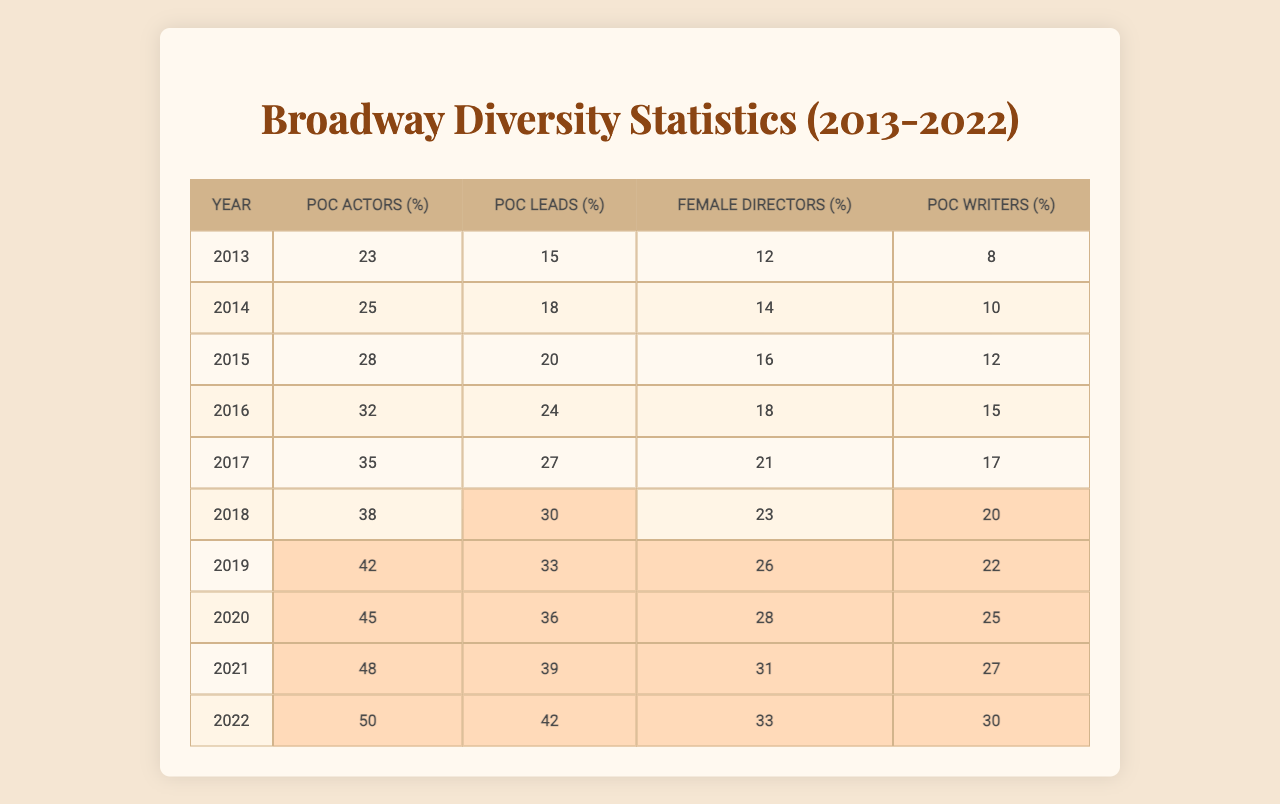What was the percentage of POC actors in 2015? From the table, the row for the year 2015 shows that the percentage of POC actors is 28%.
Answer: 28% In which year did the percentage of female directors first reach 20%? Looking at the data, the percentage of female directors first reaches 21% in 2017, as this is the first year where it is equal to or greater than 20%.
Answer: 2017 What is the average percentage of POC leads from 2019 to 2022? The percentages for POC leads from 2019 to 2022 are 33%, 36%, 39%, and 42%. Adding these together gives us 33 + 36 + 39 + 42 = 150. Dividing by 4 yields an average of 150/4 = 37.5%.
Answer: 37.5% Did the percentage of POC writers ever exceed 25% in the given years? By examining the table, the percentage of POC writers does exceed 25% in the years 2020 (25%), 2021 (27%), and 2022 (30%). Thus, the statement is true.
Answer: Yes What was the increase in the percentage of POC actors from 2013 to 2022? The percentage of POC actors in 2013 was 23% and in 2022 was 50%. The difference is calculated as 50 - 23 = 27%.
Answer: 27% In which year did the percentage of POC writers experience its highest growth compared to the previous year? Evaluating the percentages for POC writers: 8% in 2013, 10% in 2014 (2% growth), 12% in 2015 (2% growth), 15% in 2016 (3% growth), 17% in 2017 (2% growth), 20% in 2018 (3% growth), 22% in 2019 (2% growth), 25% in 2020 (3% growth), 27% in 2021 (2% growth), and 30% in 2022 (3% growth). The highest growth of 3% is observed in 2016, 2018, 2020, and 2022.
Answer: 2016, 2018, 2020, and 2022 What trend can be observed in the percentage of female directors from 2013 to 2022? Analyzing the data shows a consistent upward trend in the percentage of female directors over the years: it starts at 12% in 2013 and rises to 33% in 2022. This indicates ongoing improvement in gender diversity among directors.
Answer: Increasing trend Which year had the lowest percentage of female directors? Looking at the table, the lowest percentage of female directors was in 2013 at 12%.
Answer: 2013 What was the total percentage of POC leads across all years from 2013 to 2022? Adding the percentages of POC leads over the years gives us: 15 + 18 + 20 + 24 + 27 + 30 + 33 + 36 + 39 + 42 =  288.
Answer: 288 Is the percentage of POC actors higher than 40% in 2022? The table states that the percentage of POC actors in 2022 is 50%, which is indeed higher than 40%.
Answer: Yes 